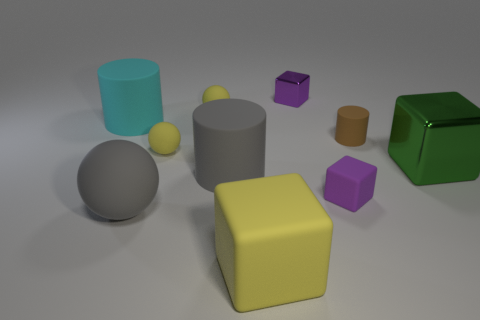Subtract all large cylinders. How many cylinders are left? 1 Subtract all gray spheres. How many spheres are left? 2 Subtract 1 blocks. How many blocks are left? 3 Subtract all spheres. How many objects are left? 7 Subtract all blue cylinders. How many yellow balls are left? 2 Subtract all small purple matte blocks. Subtract all tiny cyan matte objects. How many objects are left? 9 Add 8 tiny metallic cubes. How many tiny metallic cubes are left? 9 Add 3 cylinders. How many cylinders exist? 6 Subtract 1 yellow blocks. How many objects are left? 9 Subtract all blue blocks. Subtract all brown cylinders. How many blocks are left? 4 